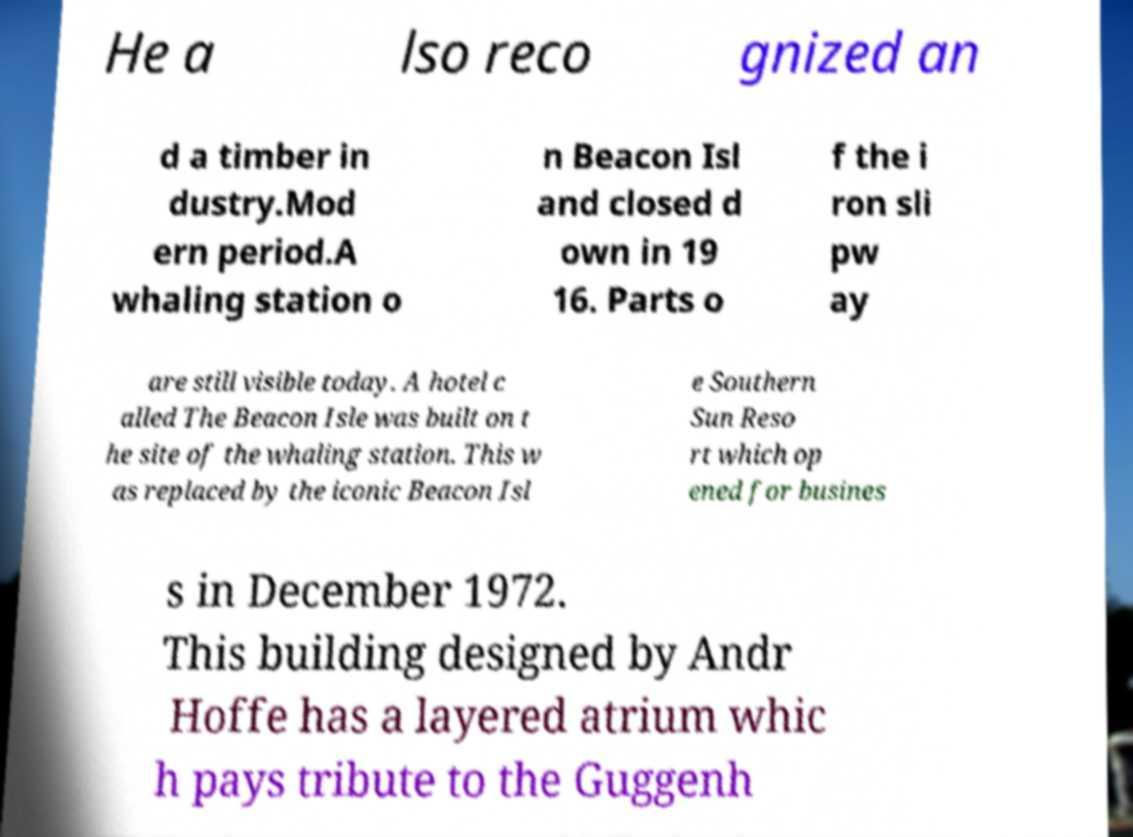Could you extract and type out the text from this image? He a lso reco gnized an d a timber in dustry.Mod ern period.A whaling station o n Beacon Isl and closed d own in 19 16. Parts o f the i ron sli pw ay are still visible today. A hotel c alled The Beacon Isle was built on t he site of the whaling station. This w as replaced by the iconic Beacon Isl e Southern Sun Reso rt which op ened for busines s in December 1972. This building designed by Andr Hoffe has a layered atrium whic h pays tribute to the Guggenh 